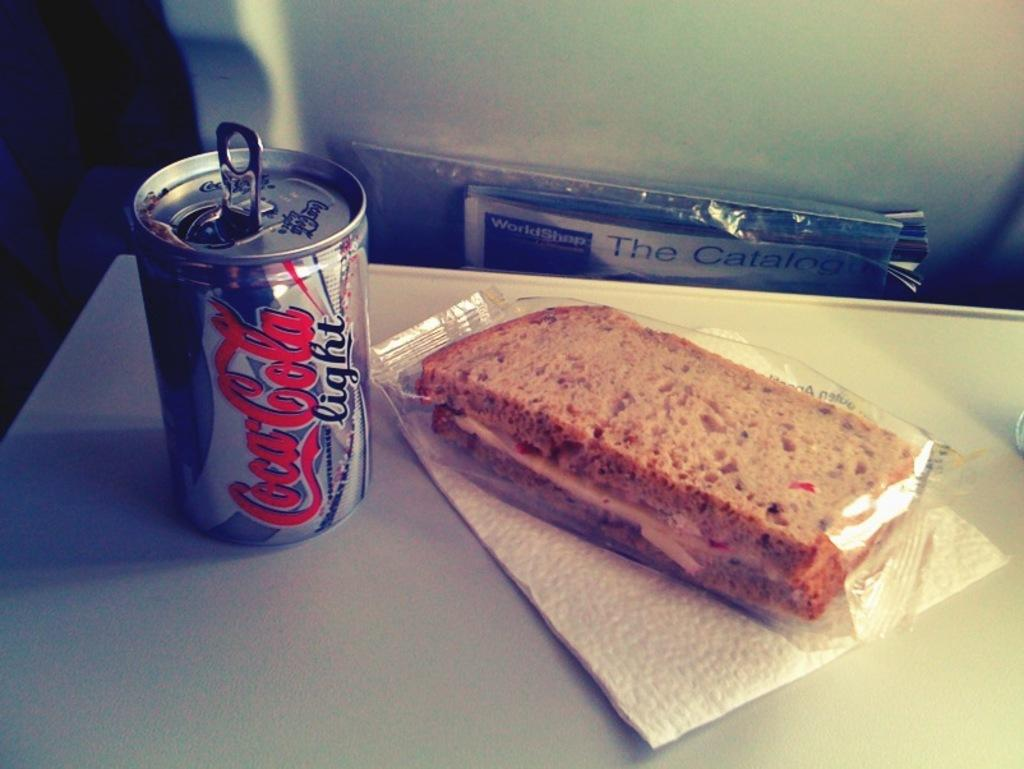What is the main subject of the image? There is a food item in the image. How is the food item being presented? The food item is covered. Where is the covered food item located? The covered food item is on a table. What else can be seen on the table? There is tissue and a coke tin on the table. Can you describe the yak grazing in the background of the image? There is no yak present in the image; it only features a covered food item on a table with tissue and a coke tin. 